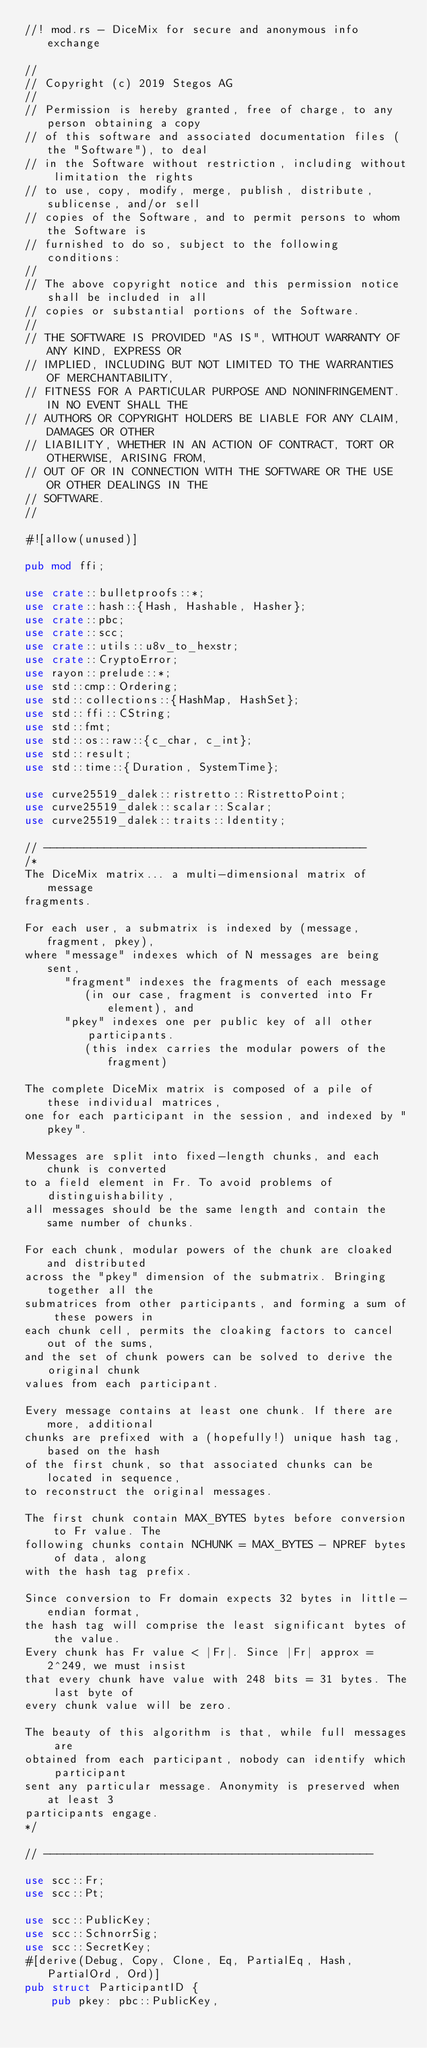<code> <loc_0><loc_0><loc_500><loc_500><_Rust_>//! mod.rs - DiceMix for secure and anonymous info exchange

//
// Copyright (c) 2019 Stegos AG
//
// Permission is hereby granted, free of charge, to any person obtaining a copy
// of this software and associated documentation files (the "Software"), to deal
// in the Software without restriction, including without limitation the rights
// to use, copy, modify, merge, publish, distribute, sublicense, and/or sell
// copies of the Software, and to permit persons to whom the Software is
// furnished to do so, subject to the following conditions:
//
// The above copyright notice and this permission notice shall be included in all
// copies or substantial portions of the Software.
//
// THE SOFTWARE IS PROVIDED "AS IS", WITHOUT WARRANTY OF ANY KIND, EXPRESS OR
// IMPLIED, INCLUDING BUT NOT LIMITED TO THE WARRANTIES OF MERCHANTABILITY,
// FITNESS FOR A PARTICULAR PURPOSE AND NONINFRINGEMENT. IN NO EVENT SHALL THE
// AUTHORS OR COPYRIGHT HOLDERS BE LIABLE FOR ANY CLAIM, DAMAGES OR OTHER
// LIABILITY, WHETHER IN AN ACTION OF CONTRACT, TORT OR OTHERWISE, ARISING FROM,
// OUT OF OR IN CONNECTION WITH THE SOFTWARE OR THE USE OR OTHER DEALINGS IN THE
// SOFTWARE.
//

#![allow(unused)]

pub mod ffi;

use crate::bulletproofs::*;
use crate::hash::{Hash, Hashable, Hasher};
use crate::pbc;
use crate::scc;
use crate::utils::u8v_to_hexstr;
use crate::CryptoError;
use rayon::prelude::*;
use std::cmp::Ordering;
use std::collections::{HashMap, HashSet};
use std::ffi::CString;
use std::fmt;
use std::os::raw::{c_char, c_int};
use std::result;
use std::time::{Duration, SystemTime};

use curve25519_dalek::ristretto::RistrettoPoint;
use curve25519_dalek::scalar::Scalar;
use curve25519_dalek::traits::Identity;

// ------------------------------------------------
/*
The DiceMix matrix... a multi-dimensional matrix of message
fragments.

For each user, a submatrix is indexed by (message, fragment, pkey),
where "message" indexes which of N messages are being sent,
      "fragment" indexes the fragments of each message
         (in our case, fragment is converted into Fr element), and
      "pkey" indexes one per public key of all other participants.
         (this index carries the modular powers of the fragment)

The complete DiceMix matrix is composed of a pile of these individual matrices,
one for each participant in the session, and indexed by "pkey".

Messages are split into fixed-length chunks, and each chunk is converted
to a field element in Fr. To avoid problems of distinguishability,
all messages should be the same length and contain the same number of chunks.

For each chunk, modular powers of the chunk are cloaked and distributed
across the "pkey" dimension of the submatrix. Bringing together all the
submatrices from other participants, and forming a sum of these powers in
each chunk cell, permits the cloaking factors to cancel out of the sums,
and the set of chunk powers can be solved to derive the original chunk
values from each participant.

Every message contains at least one chunk. If there are more, additional
chunks are prefixed with a (hopefully!) unique hash tag, based on the hash
of the first chunk, so that associated chunks can be located in sequence,
to reconstruct the original messages.

The first chunk contain MAX_BYTES bytes before conversion to Fr value. The
following chunks contain NCHUNK = MAX_BYTES - NPREF bytes of data, along
with the hash tag prefix.

Since conversion to Fr domain expects 32 bytes in little-endian format,
the hash tag will comprise the least significant bytes of the value.
Every chunk has Fr value < |Fr|. Since |Fr| approx = 2^249, we must insist
that every chunk have value with 248 bits = 31 bytes. The last byte of
every chunk value will be zero.

The beauty of this algorithm is that, while full messages are
obtained from each participant, nobody can identify which participant
sent any particular message. Anonymity is preserved when at least 3
participants engage.
*/

// -------------------------------------------------

use scc::Fr;
use scc::Pt;

use scc::PublicKey;
use scc::SchnorrSig;
use scc::SecretKey;
#[derive(Debug, Copy, Clone, Eq, PartialEq, Hash, PartialOrd, Ord)]
pub struct ParticipantID {
    pub pkey: pbc::PublicKey,</code> 